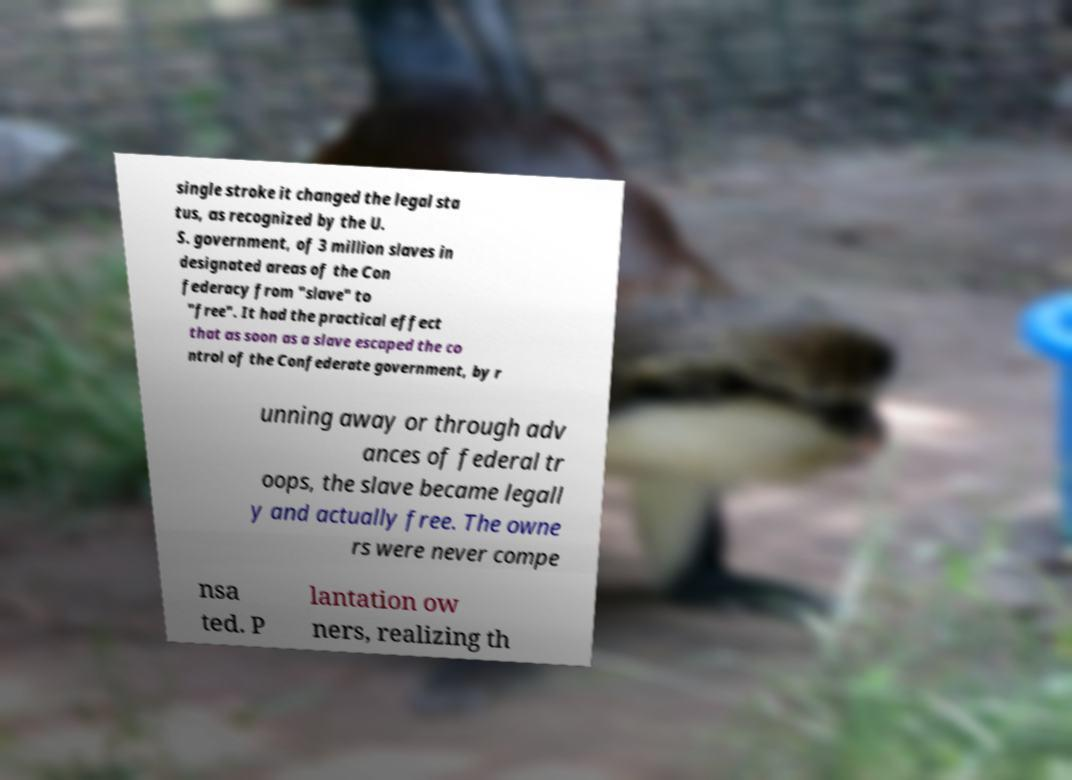There's text embedded in this image that I need extracted. Can you transcribe it verbatim? single stroke it changed the legal sta tus, as recognized by the U. S. government, of 3 million slaves in designated areas of the Con federacy from "slave" to "free". It had the practical effect that as soon as a slave escaped the co ntrol of the Confederate government, by r unning away or through adv ances of federal tr oops, the slave became legall y and actually free. The owne rs were never compe nsa ted. P lantation ow ners, realizing th 